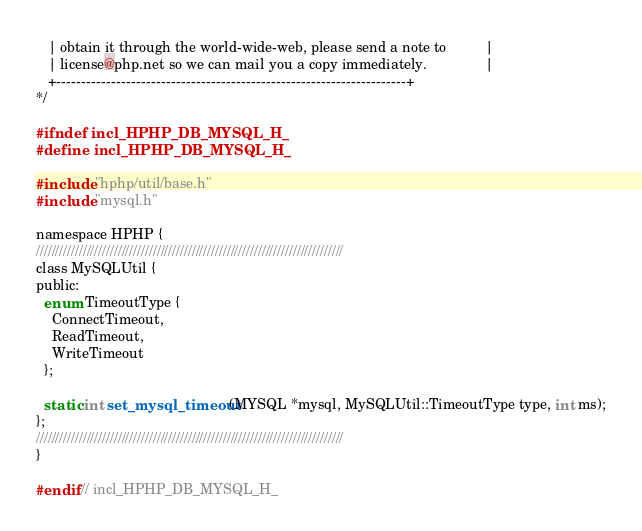Convert code to text. <code><loc_0><loc_0><loc_500><loc_500><_C_>   | obtain it through the world-wide-web, please send a note to          |
   | license@php.net so we can mail you a copy immediately.               |
   +----------------------------------------------------------------------+
*/

#ifndef incl_HPHP_DB_MYSQL_H_
#define incl_HPHP_DB_MYSQL_H_

#include "hphp/util/base.h"
#include "mysql.h"

namespace HPHP {
///////////////////////////////////////////////////////////////////////////////
class MySQLUtil {
public:
  enum TimeoutType {
    ConnectTimeout,
    ReadTimeout,
    WriteTimeout
  };

  static int set_mysql_timeout(MYSQL *mysql, MySQLUtil::TimeoutType type, int ms);
};
///////////////////////////////////////////////////////////////////////////////
}

#endif // incl_HPHP_DB_MYSQL_H_
</code> 